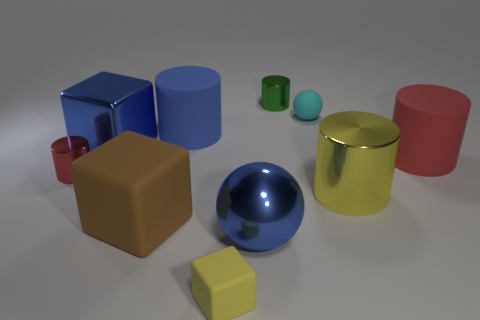Is the large sphere the same color as the metallic block?
Give a very brief answer. Yes. There is a yellow block that is made of the same material as the brown object; what is its size?
Provide a succinct answer. Small. What number of matte objects are the same color as the big shiny ball?
Ensure brevity in your answer.  1. There is a tiny matte thing that is in front of the big yellow cylinder; does it have the same color as the large metal cylinder?
Your answer should be compact. Yes. Are there an equal number of rubber cylinders in front of the tiny yellow cube and balls on the right side of the small green thing?
Your answer should be compact. No. What is the color of the tiny cylinder on the right side of the large matte block?
Offer a very short reply. Green. Are there an equal number of small yellow cubes on the right side of the yellow metallic cylinder and small cyan matte cylinders?
Give a very brief answer. Yes. How many other objects are there of the same shape as the green object?
Provide a short and direct response. 4. What number of blue spheres are behind the big yellow object?
Make the answer very short. 0. There is a rubber object that is both in front of the red rubber thing and behind the blue sphere; what size is it?
Offer a very short reply. Large. 